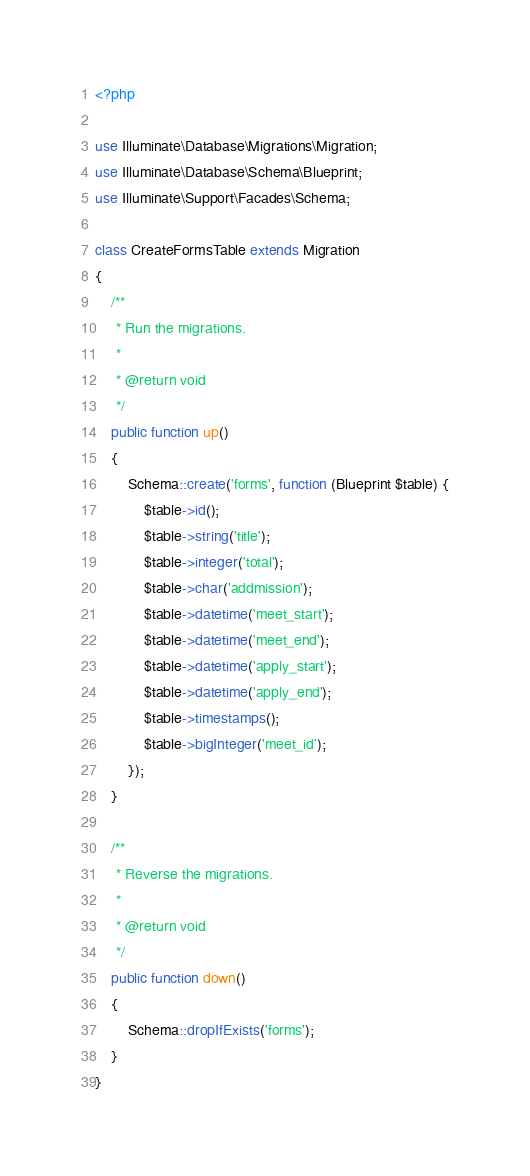<code> <loc_0><loc_0><loc_500><loc_500><_PHP_><?php

use Illuminate\Database\Migrations\Migration;
use Illuminate\Database\Schema\Blueprint;
use Illuminate\Support\Facades\Schema;

class CreateFormsTable extends Migration
{
    /**
     * Run the migrations.
     *
     * @return void
     */
    public function up()
    {
        Schema::create('forms', function (Blueprint $table) {
            $table->id();
            $table->string('title');
            $table->integer('total');
            $table->char('addmission');
            $table->datetime('meet_start');
            $table->datetime('meet_end');
            $table->datetime('apply_start');
            $table->datetime('apply_end');
            $table->timestamps();
            $table->bigInteger('meet_id');
        });
    }

    /**
     * Reverse the migrations.
     *
     * @return void
     */
    public function down()
    {
        Schema::dropIfExists('forms');
    }
}
</code> 